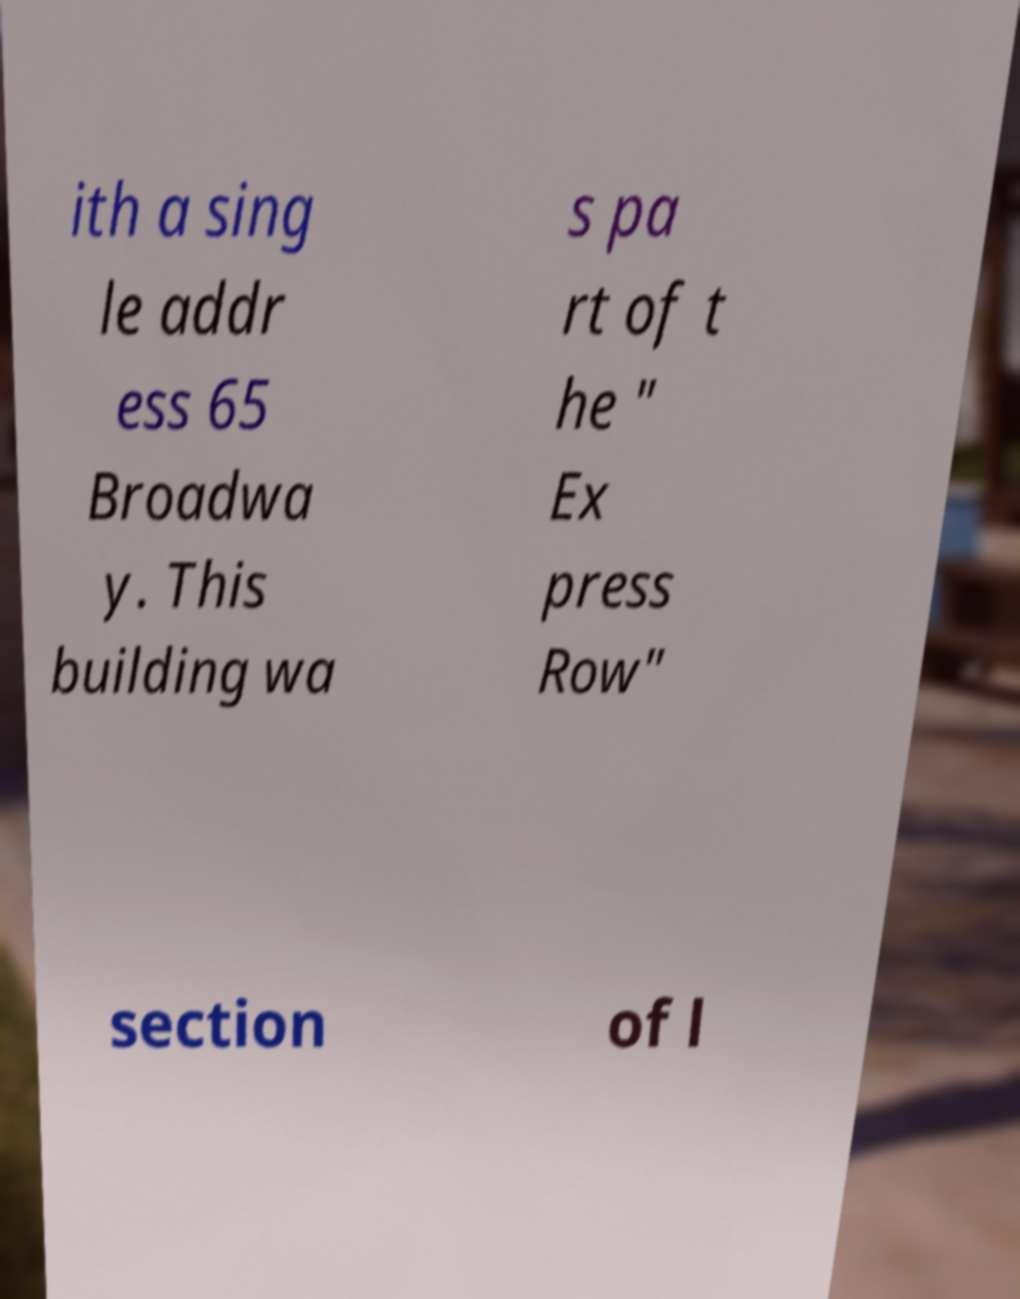Could you extract and type out the text from this image? ith a sing le addr ess 65 Broadwa y. This building wa s pa rt of t he " Ex press Row" section of l 